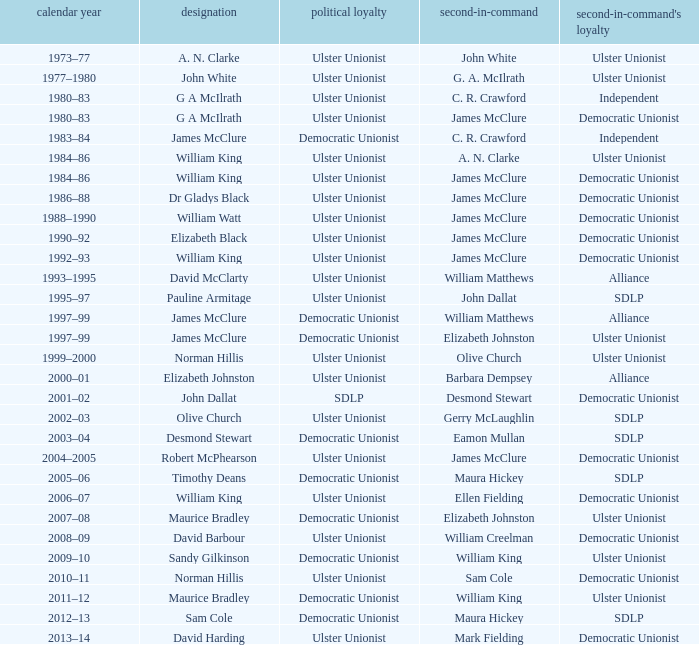What Year was james mcclure Deputy, and the Name is robert mcphearson? 2004–2005. 